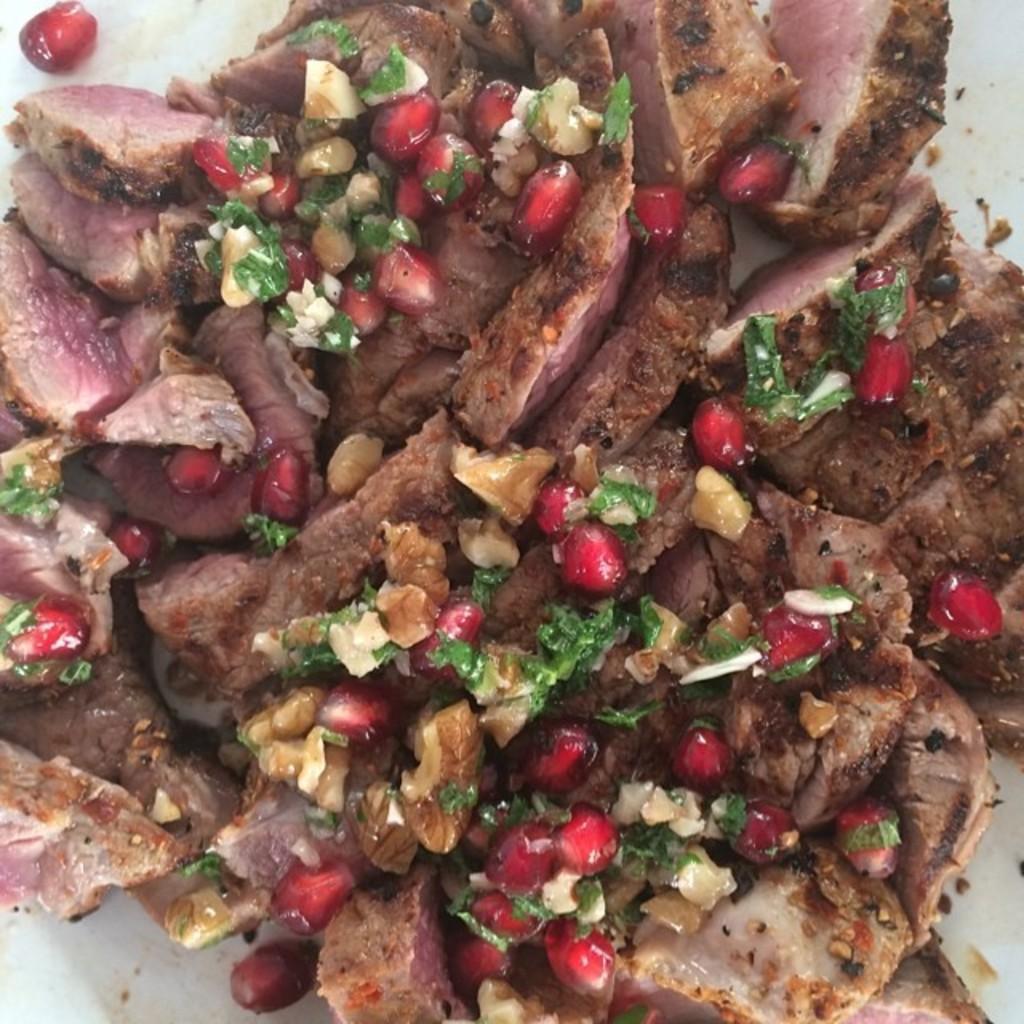Describe this image in one or two sentences. In this image we can see some food containing meat and pomegranate in a plate. 